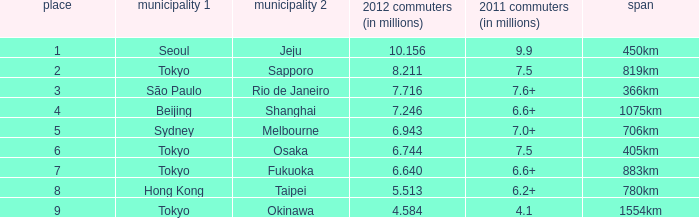What the is the first city listed on the route that had 6.6+ passengers in 2011 and a distance of 1075km? Beijing. Can you parse all the data within this table? {'header': ['place', 'municipality 1', 'municipality 2', '2012 commuters (in millions)', '2011 commuters (in millions)', 'span'], 'rows': [['1', 'Seoul', 'Jeju', '10.156', '9.9', '450km'], ['2', 'Tokyo', 'Sapporo', '8.211', '7.5', '819km'], ['3', 'São Paulo', 'Rio de Janeiro', '7.716', '7.6+', '366km'], ['4', 'Beijing', 'Shanghai', '7.246', '6.6+', '1075km'], ['5', 'Sydney', 'Melbourne', '6.943', '7.0+', '706km'], ['6', 'Tokyo', 'Osaka', '6.744', '7.5', '405km'], ['7', 'Tokyo', 'Fukuoka', '6.640', '6.6+', '883km'], ['8', 'Hong Kong', 'Taipei', '5.513', '6.2+', '780km'], ['9', 'Tokyo', 'Okinawa', '4.584', '4.1', '1554km']]} 